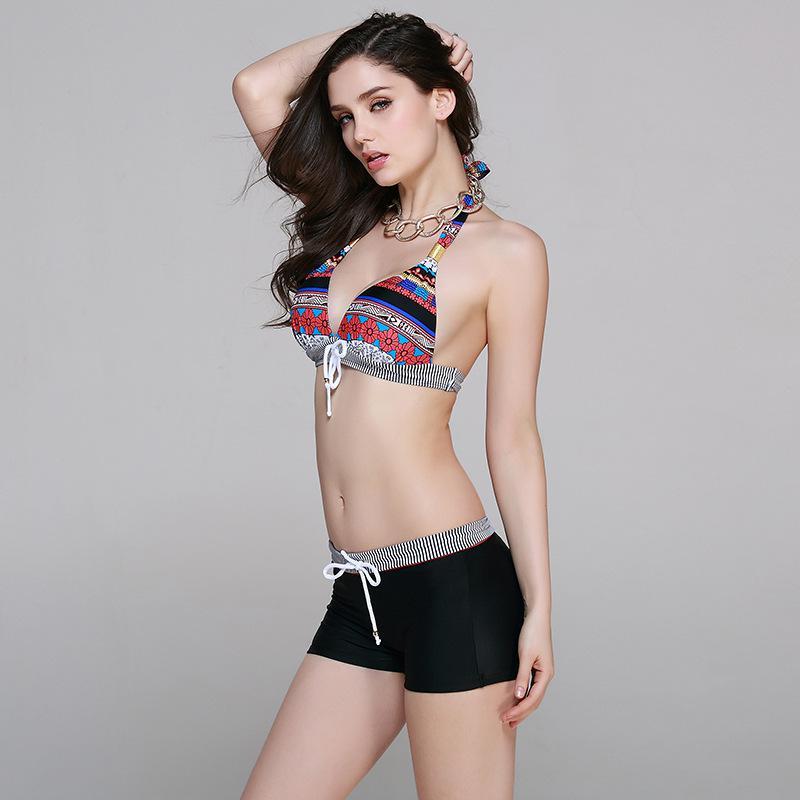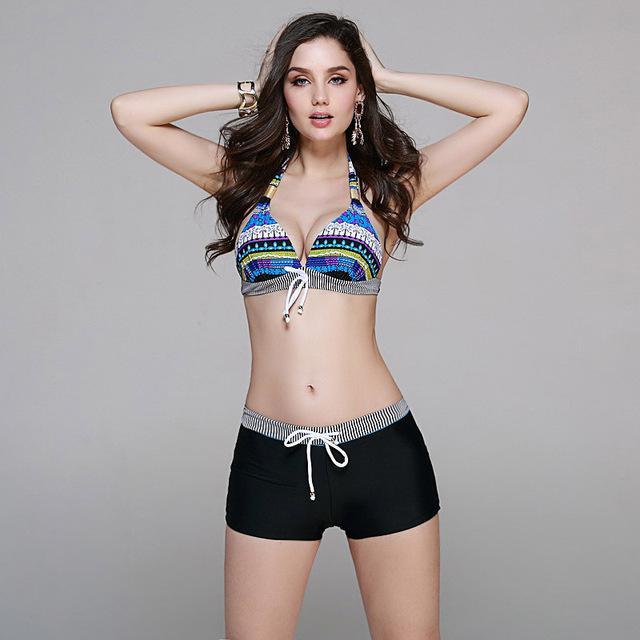The first image is the image on the left, the second image is the image on the right. Examine the images to the left and right. Is the description "All models wear bikinis with matching color tops and bottoms." accurate? Answer yes or no. No. The first image is the image on the left, the second image is the image on the right. Considering the images on both sides, is "At least part of at least one of the woman's swimwear is black." valid? Answer yes or no. Yes. 